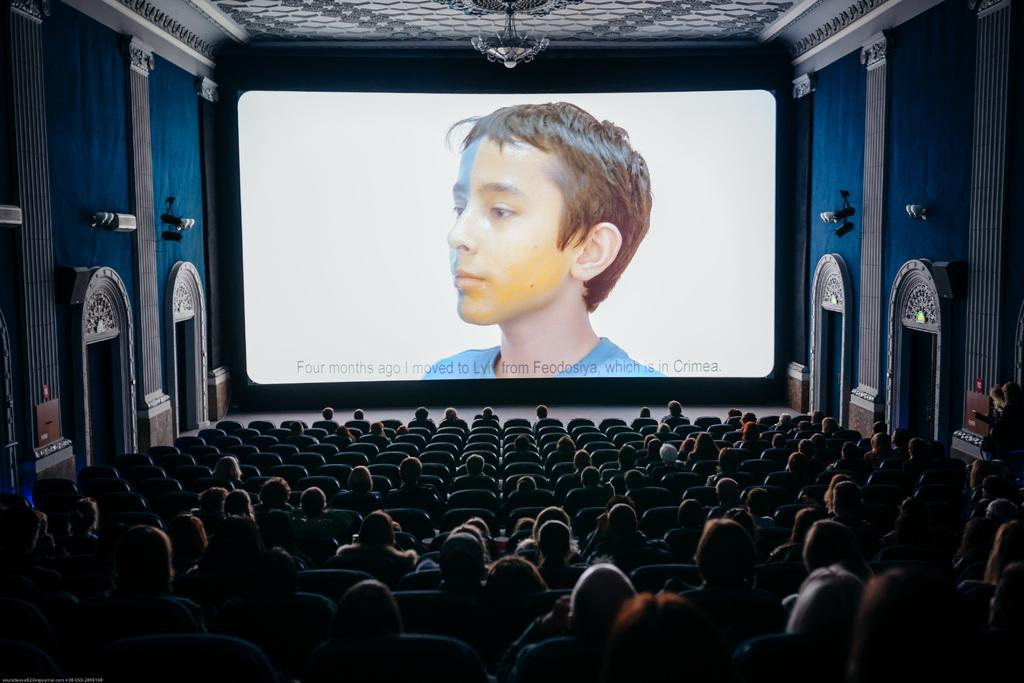What type of location is depicted in the image? The image is an inside view of a cinema hall. What are the people in the image doing? The people in the image are sitting on chairs in the cinema hall. What is the main feature of a cinema hall that can be seen in the image? There is a screen visible in the cinema hall. Are there any entrances or exits in the cinema hall? Yes, there are doors in the cinema hall. What type of game is being played on the screen in the image? There is no game being played on the screen in the image; it is a cinema hall where movies or other visual content is displayed. Can you see any feathers floating in the air in the image? There are no feathers visible in the image. 